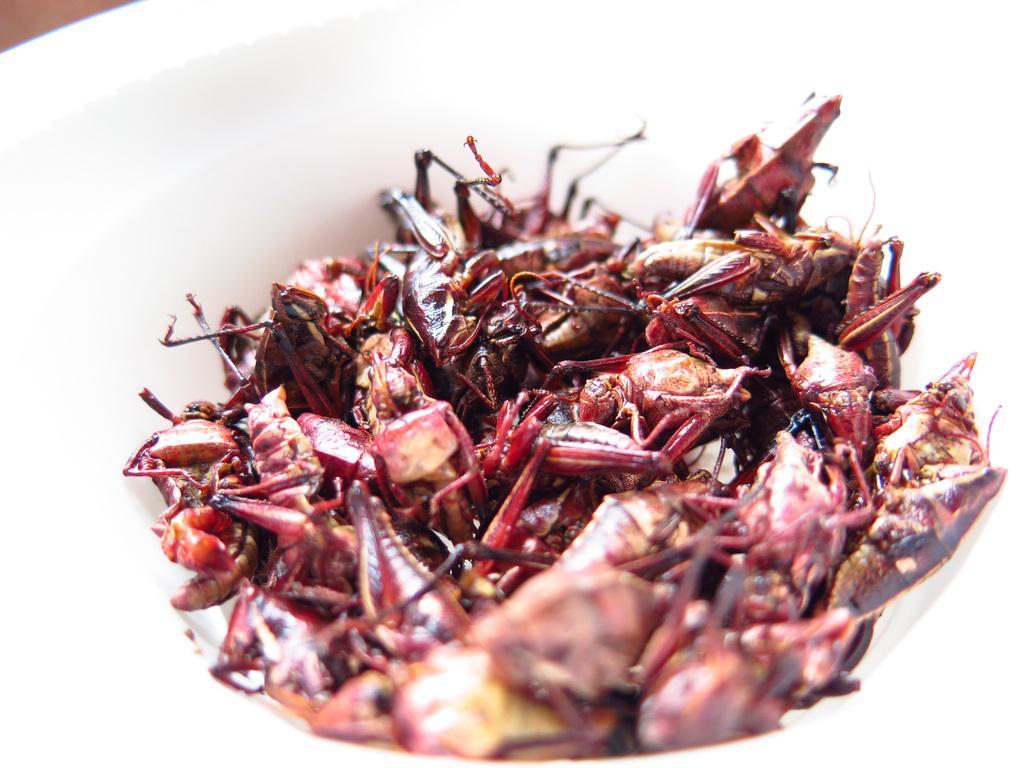Can you describe this image briefly? In this image I can see a couple of insects cooked, served in a bowl. Seems to be grasshoppers. 